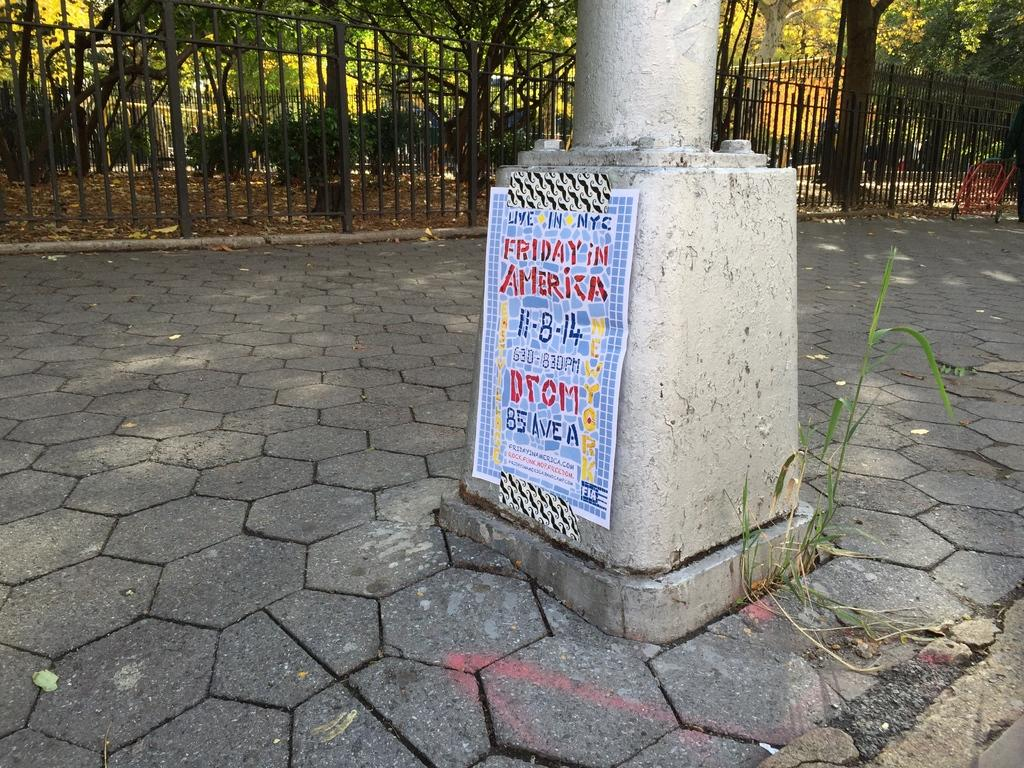What can be seen on the footpath in the image? There is a pole on the footpath in the image. What is visible in the background of the image? There is a fence in the background of the image. What type of vegetation is behind the fence in the image? There are trees behind the fence in the image. What flavor of ice cream is being served by the authority figure in the image? There is no ice cream or authority figure present in the image. What type of tail can be seen on the animal in the image? There are no animals with tails present in the image. 